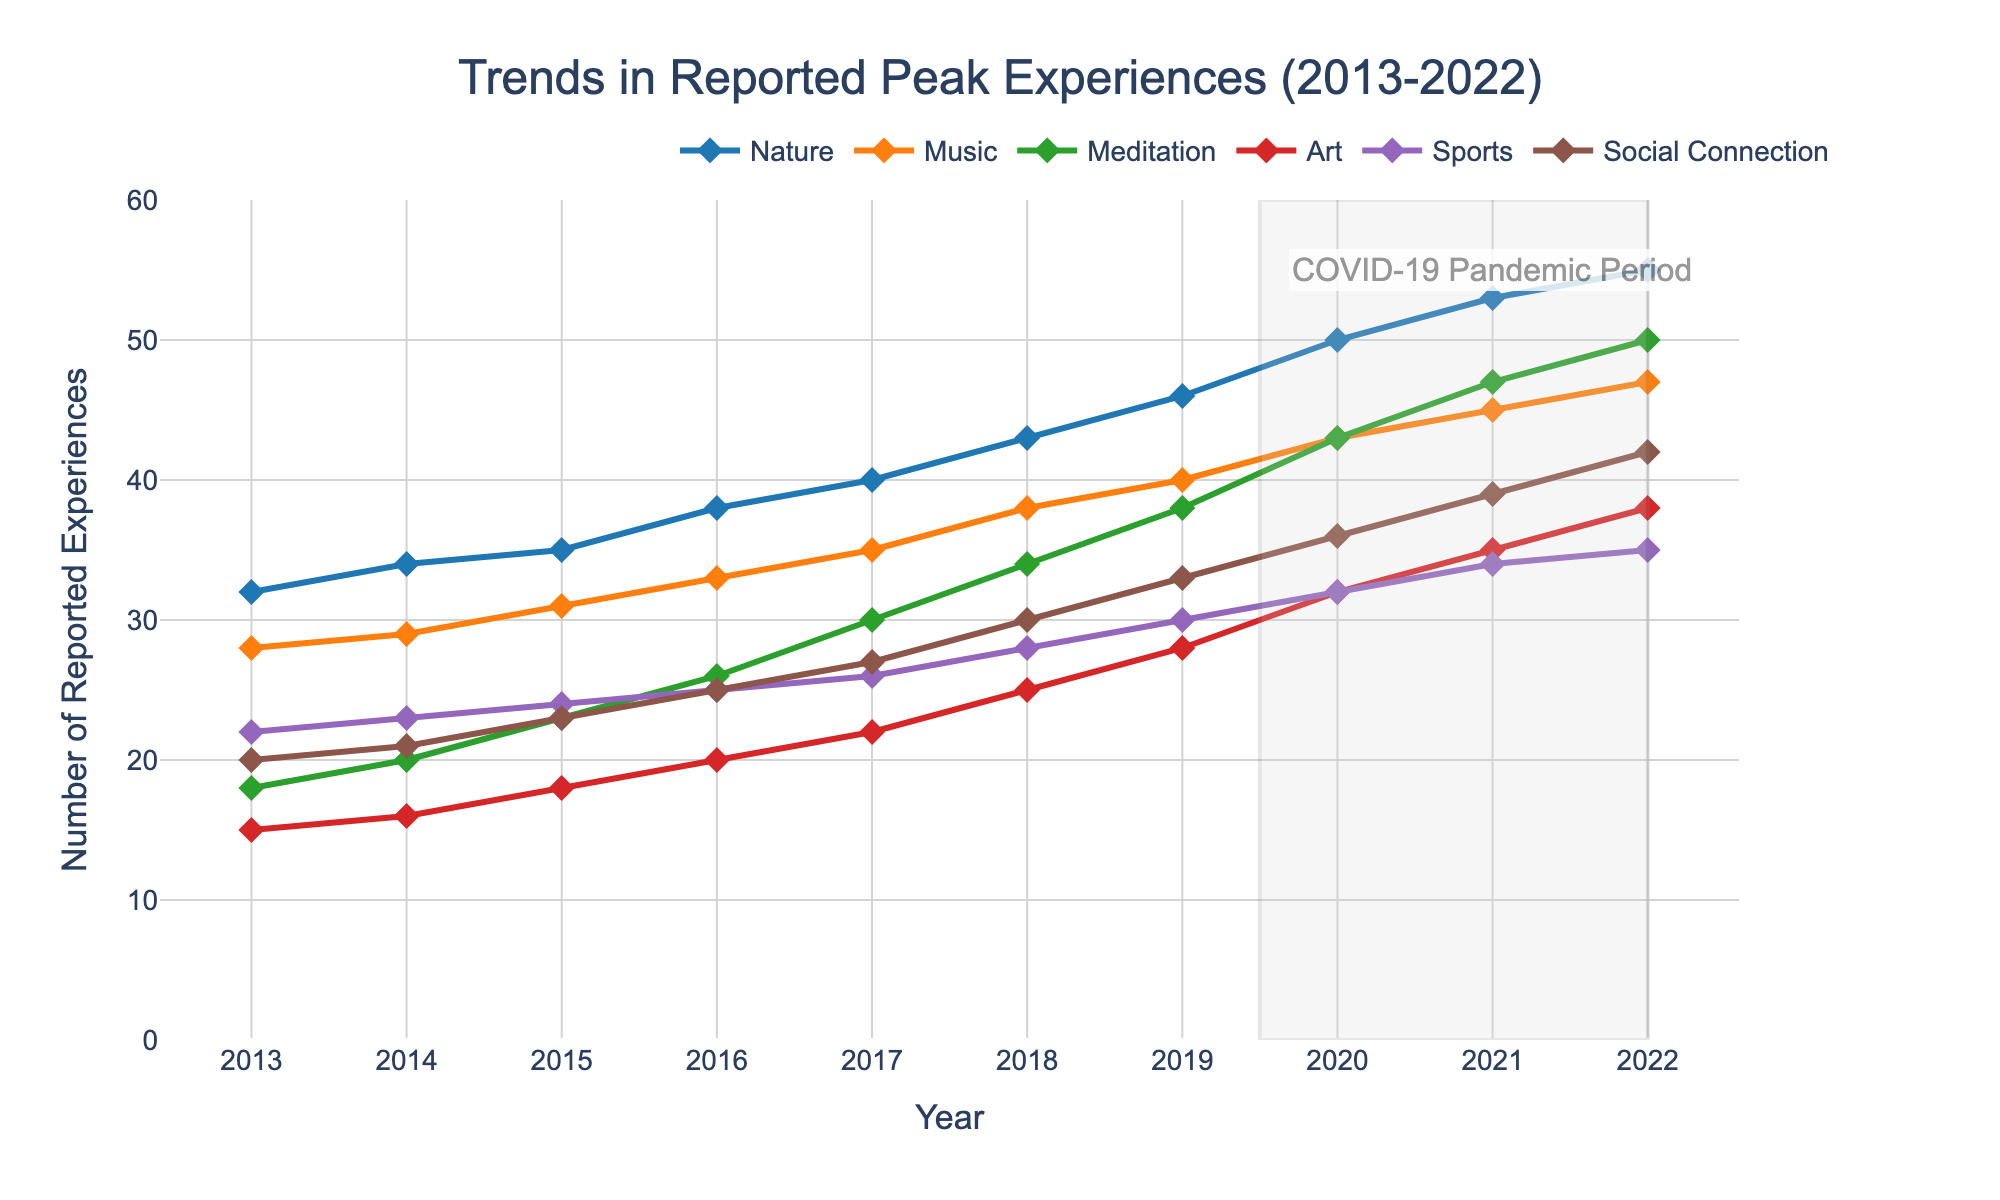What trend can be observed for peak experiences related to nature from 2013 to 2022? From the figure, the peak experiences related to nature consistently increase from 32 in 2013 to 55 in 2022. This demonstrates a clear upward trend over the 10-year period.
Answer: An increasing trend Which category of peak experiences showed the highest increase between 2013 and 2022? Compare the initial and final values for each category: Nature (32 to 55, increased by 23), Music (28 to 47, increased by 19), Meditation (18 to 50, increased by 32), Art (15 to 38, increased by 23), Sports (22 to 35, increased by 13), Social Connection (20 to 42, increased by 22). Meditation showed the highest increase.
Answer: Meditation How did the COVID-19 pandemic period (highlighted in the graph) appear to impact the number of reported peak experiences related to meditation? Between 2019 and 2022, which is the pandemic period, the reports of peak experiences related to meditation increased significantly from 38 in 2019 to 50 in 2022. This suggests a notable increase during the highlighted period.
Answer: Increase Between which years did the peak experiences related to sports show the largest year-on-year increase? Check the yearly differences: 2013-2014 (22 to 23, increased by 1), 2014-2015 (23 to 24, increased by 1), 2015-2016 (24 to 25, increased by 1), 2016-2017 (25 to 26, increased by 1), 2017-2018 (26 to 28, increased by 2), 2018-2019 (28 to 30, increased by 2), 2019-2020 (30 to 32, increased by 2), 2020-2021 (32 to 34, increased by 2), 2021-2022 (34 to 35, increased by 1). The largest year-on-year increase, which was by 2, occurred in 2017-2018, 2018-2019, and 2019-2020.
Answer: 2017-2018, 2018-2019, 2019-2020 Which category had the smallest number of reported peak experiences in 2020? Look at the data points for 2020: Nature (50), Music (43), Meditation (43), Art (32), Sports (32), Social Connection (36). The smallest number is for Art and Sports, both at 32.
Answer: Art and Sports What is the overall trend observed for peak experiences related to social connection from 2013 to 2022? From the figure, the peak experiences related to social connection consistently increase from 20 in 2013 to 42 in 2022. This shows a clear increasing trend over the 10-year period.
Answer: Increasing trend 